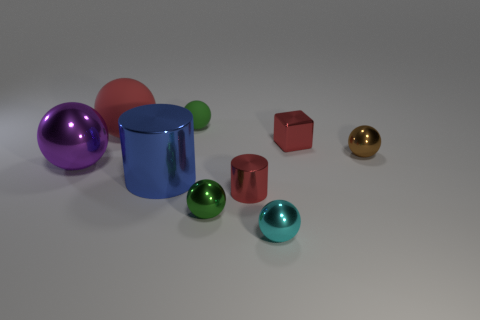There is a metal object that is the same color as the shiny block; what is its shape?
Make the answer very short. Cylinder. Are there any tiny blocks made of the same material as the cyan thing?
Give a very brief answer. Yes. Is there anything else that has the same material as the cyan object?
Your answer should be very brief. Yes. What is the material of the ball in front of the small green thing in front of the blue cylinder?
Offer a terse response. Metal. How big is the red metal thing that is right of the red shiny object that is left of the tiny red metallic thing right of the tiny cyan sphere?
Your answer should be compact. Small. What number of other things are there of the same shape as the cyan thing?
Ensure brevity in your answer.  5. There is a metal ball right of the tiny cyan sphere; does it have the same color as the shiny cylinder that is right of the green rubber sphere?
Give a very brief answer. No. There is a rubber ball that is the same size as the red block; what is its color?
Offer a terse response. Green. Is there a small metal cylinder that has the same color as the large metallic ball?
Make the answer very short. No. There is a red metallic thing to the left of the cyan shiny thing; is it the same size as the big purple shiny object?
Your response must be concise. No. 